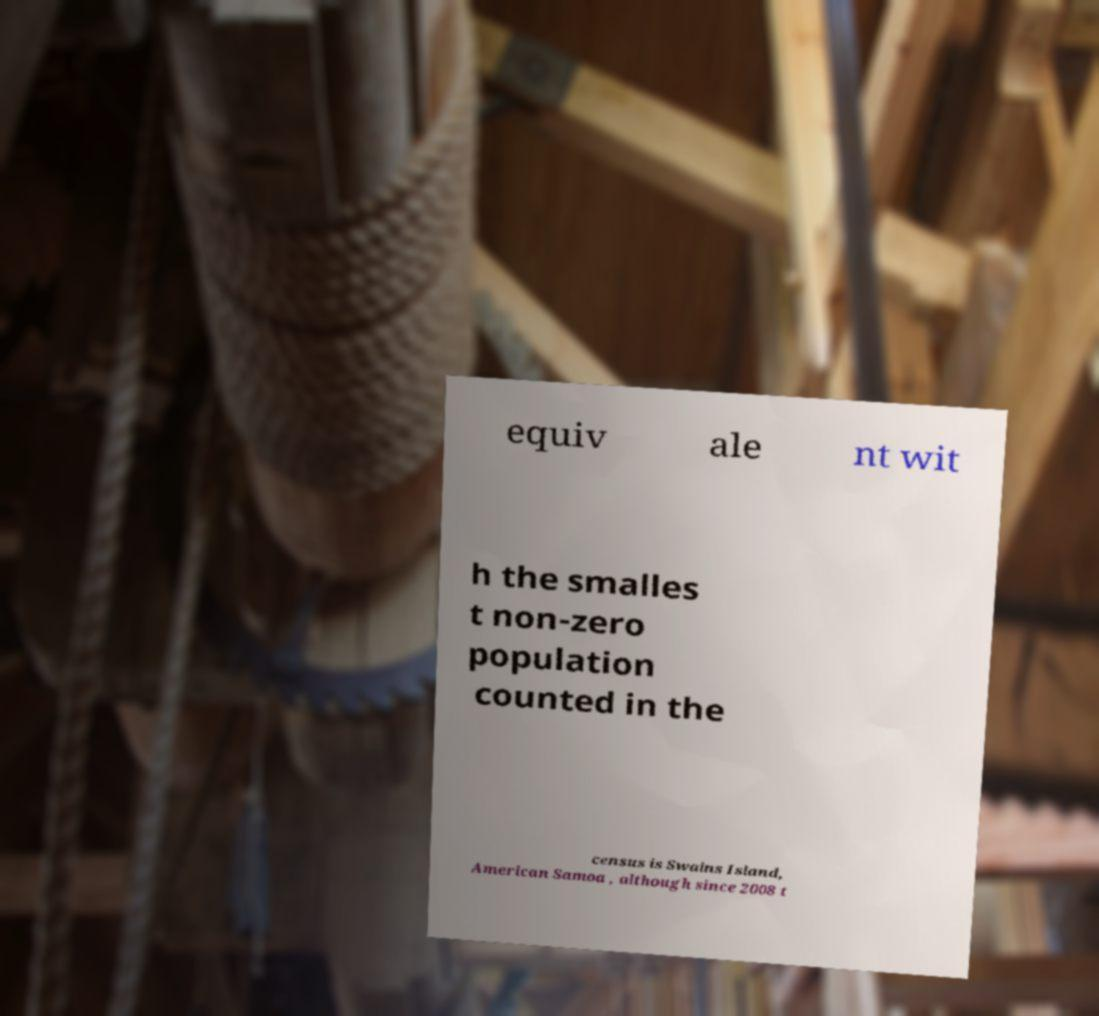Could you extract and type out the text from this image? equiv ale nt wit h the smalles t non-zero population counted in the census is Swains Island, American Samoa , although since 2008 t 